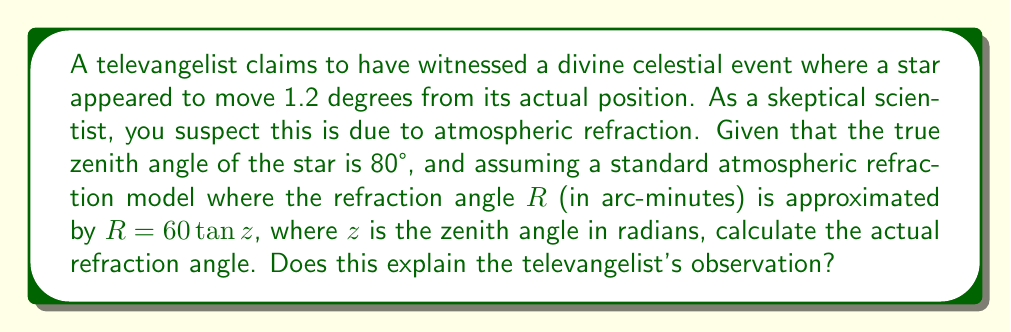Can you answer this question? Let's approach this step-by-step:

1) First, we need to convert the true zenith angle from degrees to radians:
   $z = 80° \times \frac{\pi}{180°} = 1.3963$ radians

2) Now, we can use the given formula to calculate the refraction angle $R$ in arc-minutes:
   $R = 60 \tan z = 60 \tan(1.3963)$

3) Let's calculate this:
   $R = 60 \times 5.6713 = 340.28$ arc-minutes

4) We need to convert this to degrees:
   $R_{degrees} = 340.28' \times \frac{1°}{60'} = 5.67°$

5) The televangelist claimed a movement of 1.2°. Our calculation shows a refraction of 5.67°, which is significantly larger.

6) This discrepancy suggests that atmospheric refraction could indeed account for the observed phenomenon, and potentially even a more dramatic effect than what was reported.
Answer: $R = 5.67°$, which exceeds and thus explains the claimed 1.2° shift. 